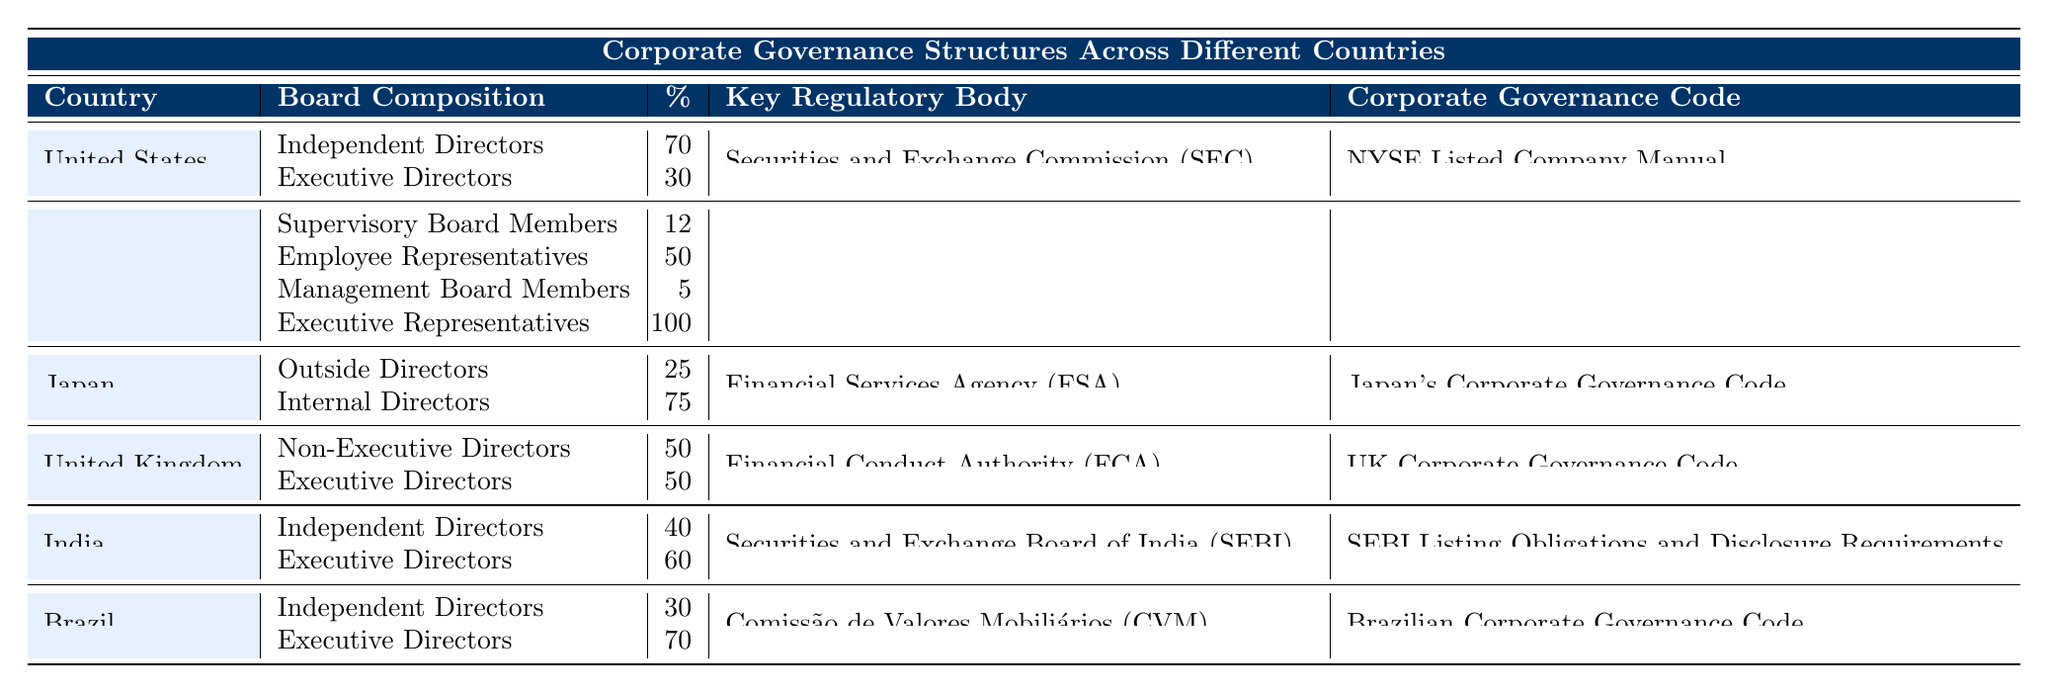What percentage of the board in the United States comprises independent directors? The table states that in the United States, 70% of the board is composed of independent directors. This value is explicitly mentioned under the board composition for the US.
Answer: 70 How many members are on Germany's supervisory board? According to the table, Germany's supervisory board consists of 12 members. This information is directly available in the board composition section for Germany.
Answer: 12 Which country has the highest percentage of executive directors? Brazil has the highest percentage of executive directors at 70%, as per the data shown in the table. This is derived by comparing the executive directors' percentages in each country listed.
Answer: Brazil Is the Financial Services Agency listed as the key regulatory body for Japan? Yes, the Financial Services Agency (FSA) is indeed listed as the key regulatory body for Japan, as reflected in the table. This is directly indicated in the key regulatory body column for Japan.
Answer: Yes What is the combined percentage of independent and executive directors in India? The combined percentage for India can be computed by summing the percentage of independent directors (40%) and executive directors (60%). This results in 40 + 60 = 100%.
Answer: 100 In which country does the board have a balance of 50% non-executive and 50% executive directors? The United Kingdom has a board composition of 50% non-executive directors and 50% executive directors, as shown in the respective section of the table. This is identified by looking at the board composition for the UK.
Answer: United Kingdom Which country has a corporate governance code specifically named after it? Each country has a corporate governance code associated with it; however, naming varies. Japan's corporate governance code is directly referred to as "Japan's Corporate Governance Code". This distinction is noted under the corporate governance code for Japan.
Answer: Japan What is the percentage of employee representatives in Germany's supervisory board? The table indicates that 50% of the supervisory board consists of employee representatives, as specified in the board composition for Germany. This is a specific figure listed in the table.
Answer: 50 Which country uses the NYSE Listed Company Manual as its corporate governance code? The United States uses the NYSE Listed Company Manual as its corporate governance code, as detailed in the table. This information is found in the corporate governance code section for the US.
Answer: United States 